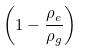Convert formula to latex. <formula><loc_0><loc_0><loc_500><loc_500>\left ( 1 - { \frac { \rho _ { e } } { \rho _ { g } } } \right )</formula> 